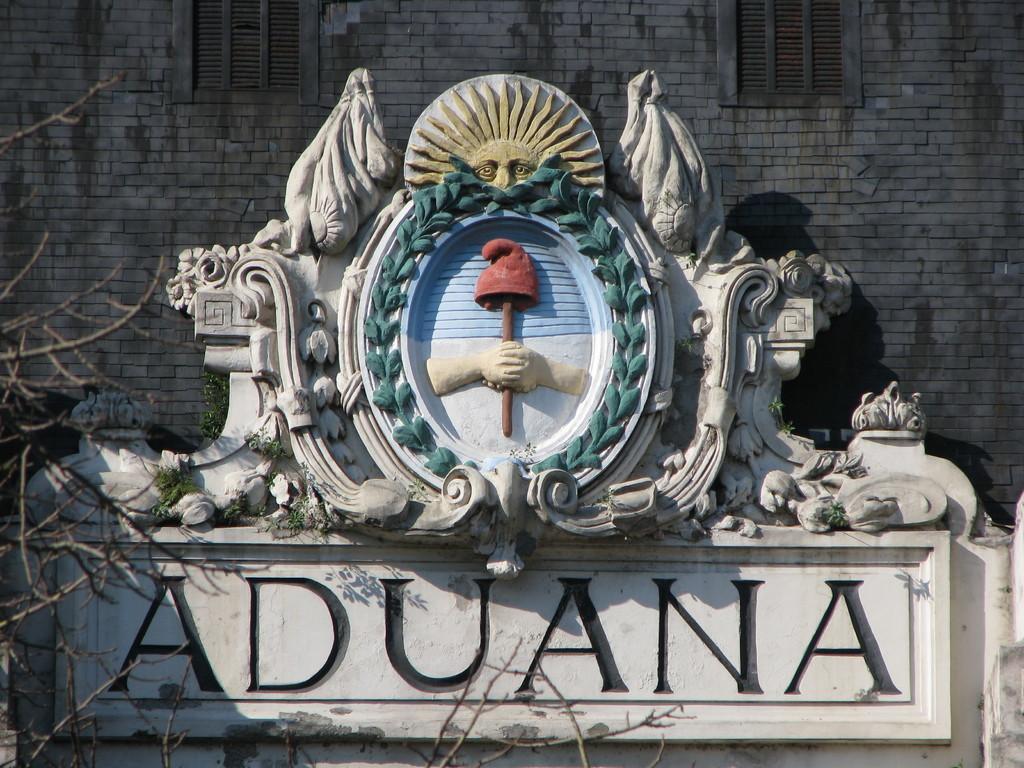Could you give a brief overview of what you see in this image? In this image we can see a statue and some text under it. We can also see some branches of a tree, some plants, a wall and windows. 